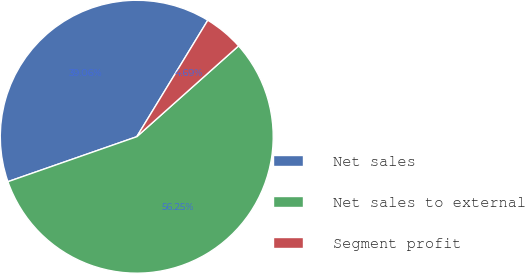Convert chart. <chart><loc_0><loc_0><loc_500><loc_500><pie_chart><fcel>Net sales<fcel>Net sales to external<fcel>Segment profit<nl><fcel>39.06%<fcel>56.25%<fcel>4.69%<nl></chart> 